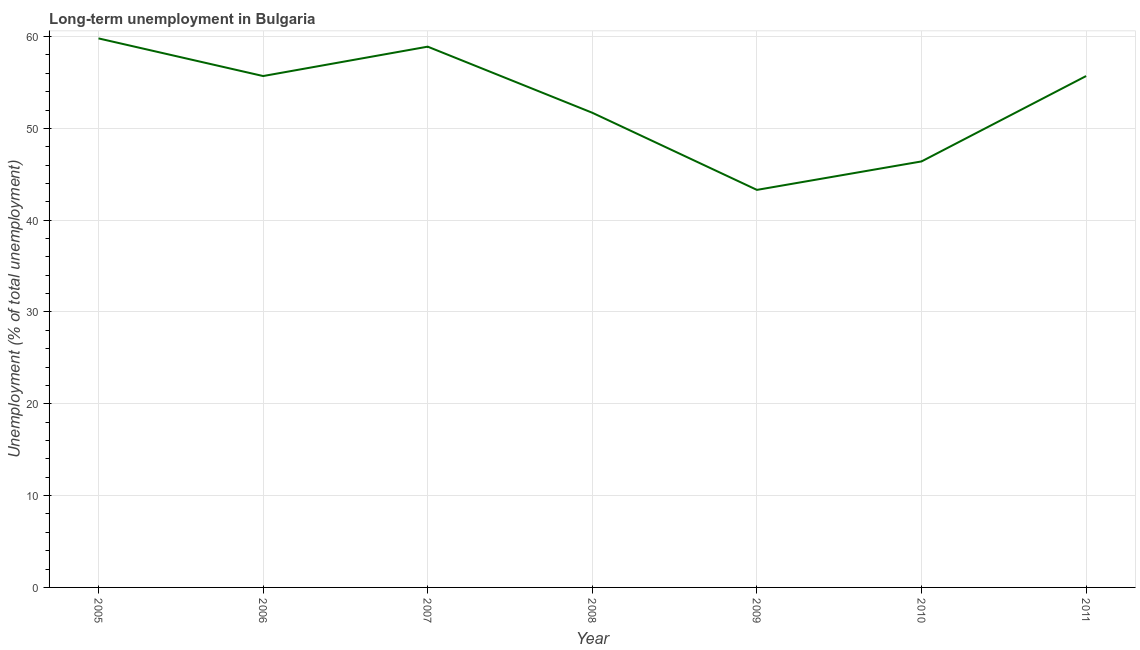What is the long-term unemployment in 2006?
Give a very brief answer. 55.7. Across all years, what is the maximum long-term unemployment?
Ensure brevity in your answer.  59.8. Across all years, what is the minimum long-term unemployment?
Ensure brevity in your answer.  43.3. In which year was the long-term unemployment maximum?
Give a very brief answer. 2005. What is the sum of the long-term unemployment?
Ensure brevity in your answer.  371.5. What is the average long-term unemployment per year?
Provide a short and direct response. 53.07. What is the median long-term unemployment?
Your response must be concise. 55.7. In how many years, is the long-term unemployment greater than 26 %?
Offer a terse response. 7. Do a majority of the years between 2010 and 2005 (inclusive) have long-term unemployment greater than 38 %?
Make the answer very short. Yes. What is the ratio of the long-term unemployment in 2005 to that in 2009?
Ensure brevity in your answer.  1.38. Is the difference between the long-term unemployment in 2009 and 2011 greater than the difference between any two years?
Ensure brevity in your answer.  No. What is the difference between the highest and the second highest long-term unemployment?
Keep it short and to the point. 0.9. Is the sum of the long-term unemployment in 2006 and 2010 greater than the maximum long-term unemployment across all years?
Your answer should be compact. Yes. What is the difference between the highest and the lowest long-term unemployment?
Your answer should be compact. 16.5. In how many years, is the long-term unemployment greater than the average long-term unemployment taken over all years?
Give a very brief answer. 4. Does the long-term unemployment monotonically increase over the years?
Your answer should be very brief. No. How many years are there in the graph?
Keep it short and to the point. 7. What is the difference between two consecutive major ticks on the Y-axis?
Your response must be concise. 10. What is the title of the graph?
Provide a short and direct response. Long-term unemployment in Bulgaria. What is the label or title of the X-axis?
Provide a succinct answer. Year. What is the label or title of the Y-axis?
Keep it short and to the point. Unemployment (% of total unemployment). What is the Unemployment (% of total unemployment) in 2005?
Your answer should be compact. 59.8. What is the Unemployment (% of total unemployment) of 2006?
Offer a very short reply. 55.7. What is the Unemployment (% of total unemployment) of 2007?
Provide a short and direct response. 58.9. What is the Unemployment (% of total unemployment) of 2008?
Provide a short and direct response. 51.7. What is the Unemployment (% of total unemployment) in 2009?
Give a very brief answer. 43.3. What is the Unemployment (% of total unemployment) of 2010?
Keep it short and to the point. 46.4. What is the Unemployment (% of total unemployment) of 2011?
Provide a succinct answer. 55.7. What is the difference between the Unemployment (% of total unemployment) in 2005 and 2008?
Keep it short and to the point. 8.1. What is the difference between the Unemployment (% of total unemployment) in 2005 and 2011?
Offer a terse response. 4.1. What is the difference between the Unemployment (% of total unemployment) in 2006 and 2007?
Keep it short and to the point. -3.2. What is the difference between the Unemployment (% of total unemployment) in 2006 and 2008?
Give a very brief answer. 4. What is the difference between the Unemployment (% of total unemployment) in 2006 and 2010?
Give a very brief answer. 9.3. What is the difference between the Unemployment (% of total unemployment) in 2006 and 2011?
Your response must be concise. 0. What is the difference between the Unemployment (% of total unemployment) in 2007 and 2009?
Offer a terse response. 15.6. What is the difference between the Unemployment (% of total unemployment) in 2007 and 2010?
Make the answer very short. 12.5. What is the difference between the Unemployment (% of total unemployment) in 2008 and 2009?
Provide a short and direct response. 8.4. What is the difference between the Unemployment (% of total unemployment) in 2008 and 2010?
Your answer should be compact. 5.3. What is the difference between the Unemployment (% of total unemployment) in 2009 and 2011?
Provide a short and direct response. -12.4. What is the difference between the Unemployment (% of total unemployment) in 2010 and 2011?
Make the answer very short. -9.3. What is the ratio of the Unemployment (% of total unemployment) in 2005 to that in 2006?
Keep it short and to the point. 1.07. What is the ratio of the Unemployment (% of total unemployment) in 2005 to that in 2008?
Your answer should be compact. 1.16. What is the ratio of the Unemployment (% of total unemployment) in 2005 to that in 2009?
Provide a succinct answer. 1.38. What is the ratio of the Unemployment (% of total unemployment) in 2005 to that in 2010?
Make the answer very short. 1.29. What is the ratio of the Unemployment (% of total unemployment) in 2005 to that in 2011?
Provide a short and direct response. 1.07. What is the ratio of the Unemployment (% of total unemployment) in 2006 to that in 2007?
Your answer should be compact. 0.95. What is the ratio of the Unemployment (% of total unemployment) in 2006 to that in 2008?
Ensure brevity in your answer.  1.08. What is the ratio of the Unemployment (% of total unemployment) in 2006 to that in 2009?
Offer a terse response. 1.29. What is the ratio of the Unemployment (% of total unemployment) in 2006 to that in 2010?
Give a very brief answer. 1.2. What is the ratio of the Unemployment (% of total unemployment) in 2007 to that in 2008?
Your answer should be very brief. 1.14. What is the ratio of the Unemployment (% of total unemployment) in 2007 to that in 2009?
Keep it short and to the point. 1.36. What is the ratio of the Unemployment (% of total unemployment) in 2007 to that in 2010?
Ensure brevity in your answer.  1.27. What is the ratio of the Unemployment (% of total unemployment) in 2007 to that in 2011?
Your answer should be very brief. 1.06. What is the ratio of the Unemployment (% of total unemployment) in 2008 to that in 2009?
Your response must be concise. 1.19. What is the ratio of the Unemployment (% of total unemployment) in 2008 to that in 2010?
Your response must be concise. 1.11. What is the ratio of the Unemployment (% of total unemployment) in 2008 to that in 2011?
Provide a short and direct response. 0.93. What is the ratio of the Unemployment (% of total unemployment) in 2009 to that in 2010?
Give a very brief answer. 0.93. What is the ratio of the Unemployment (% of total unemployment) in 2009 to that in 2011?
Your response must be concise. 0.78. What is the ratio of the Unemployment (% of total unemployment) in 2010 to that in 2011?
Offer a terse response. 0.83. 